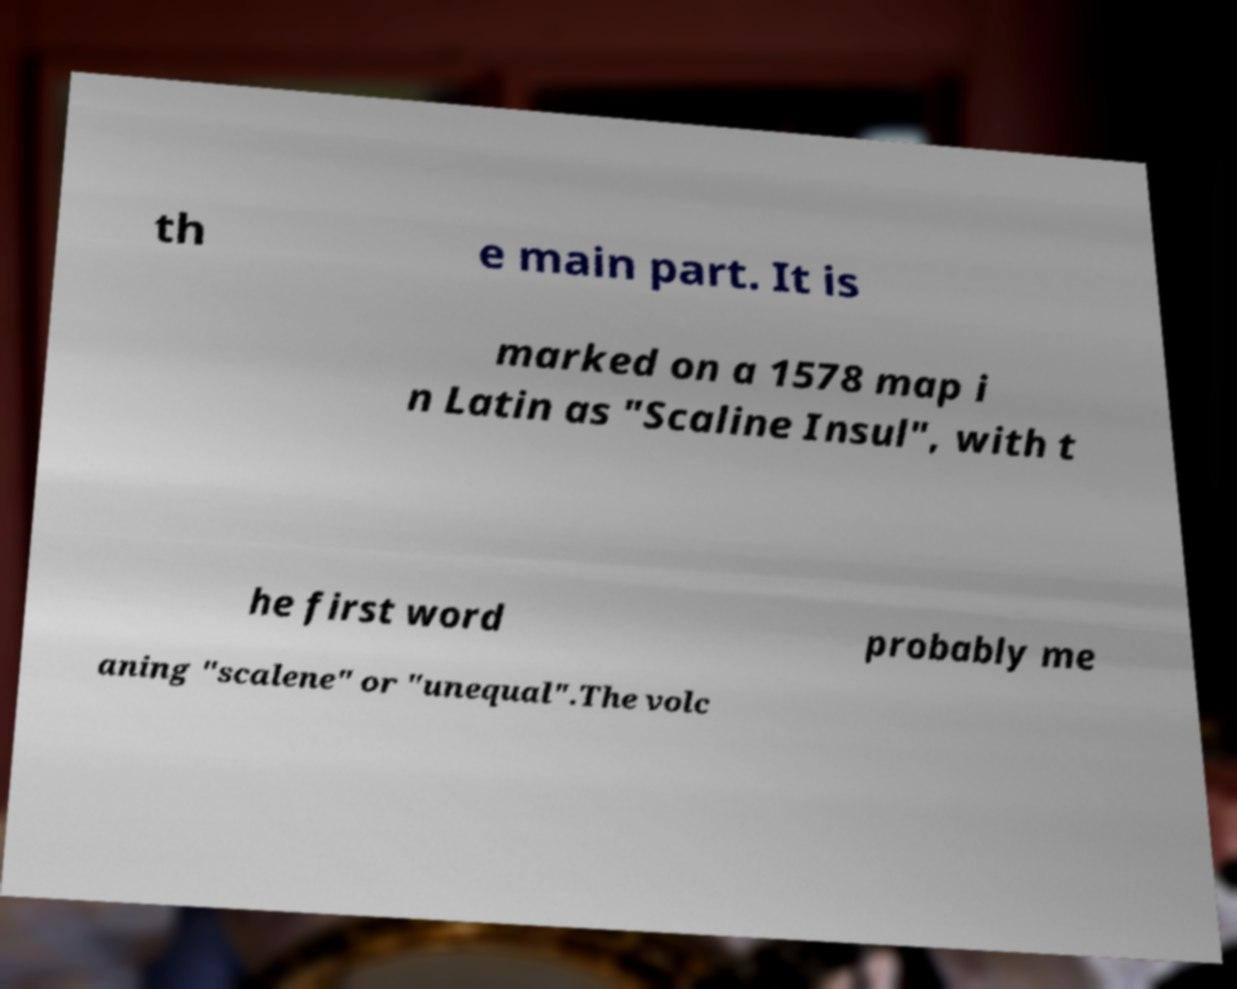Please identify and transcribe the text found in this image. th e main part. It is marked on a 1578 map i n Latin as "Scaline Insul", with t he first word probably me aning "scalene" or "unequal".The volc 